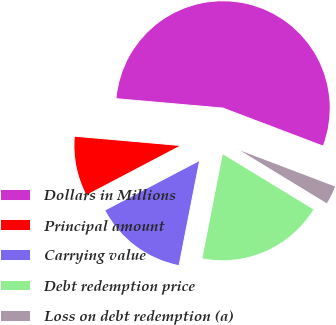Convert chart. <chart><loc_0><loc_0><loc_500><loc_500><pie_chart><fcel>Dollars in Millions<fcel>Principal amount<fcel>Carrying value<fcel>Debt redemption price<fcel>Loss on debt redemption (a)<nl><fcel>54.38%<fcel>9.09%<fcel>14.23%<fcel>19.37%<fcel>2.94%<nl></chart> 